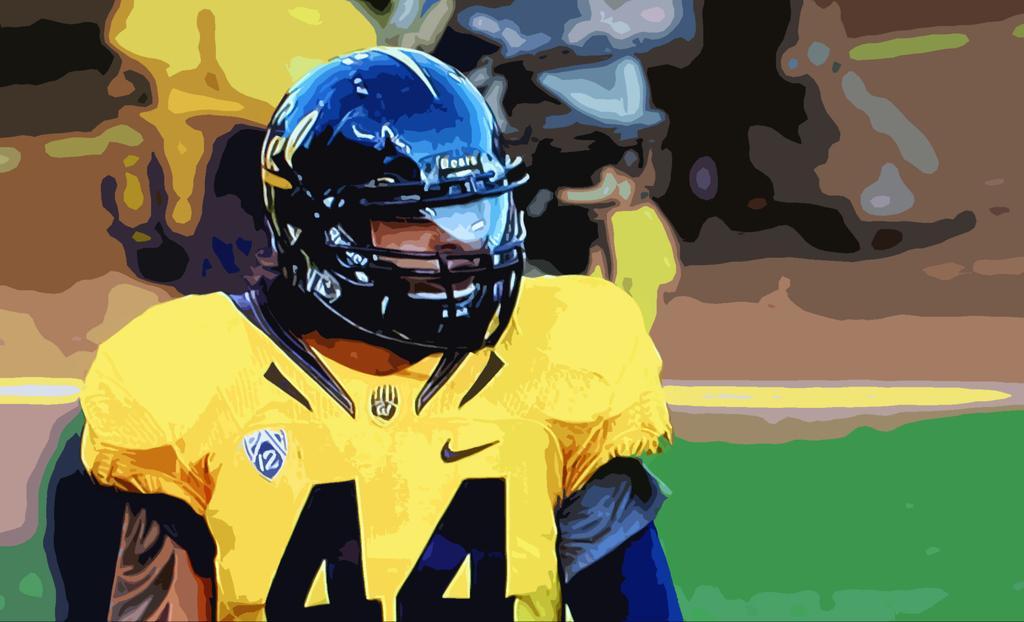Describe this image in one or two sentences. In this image we can see a painting of a person with uniform, helmet. 